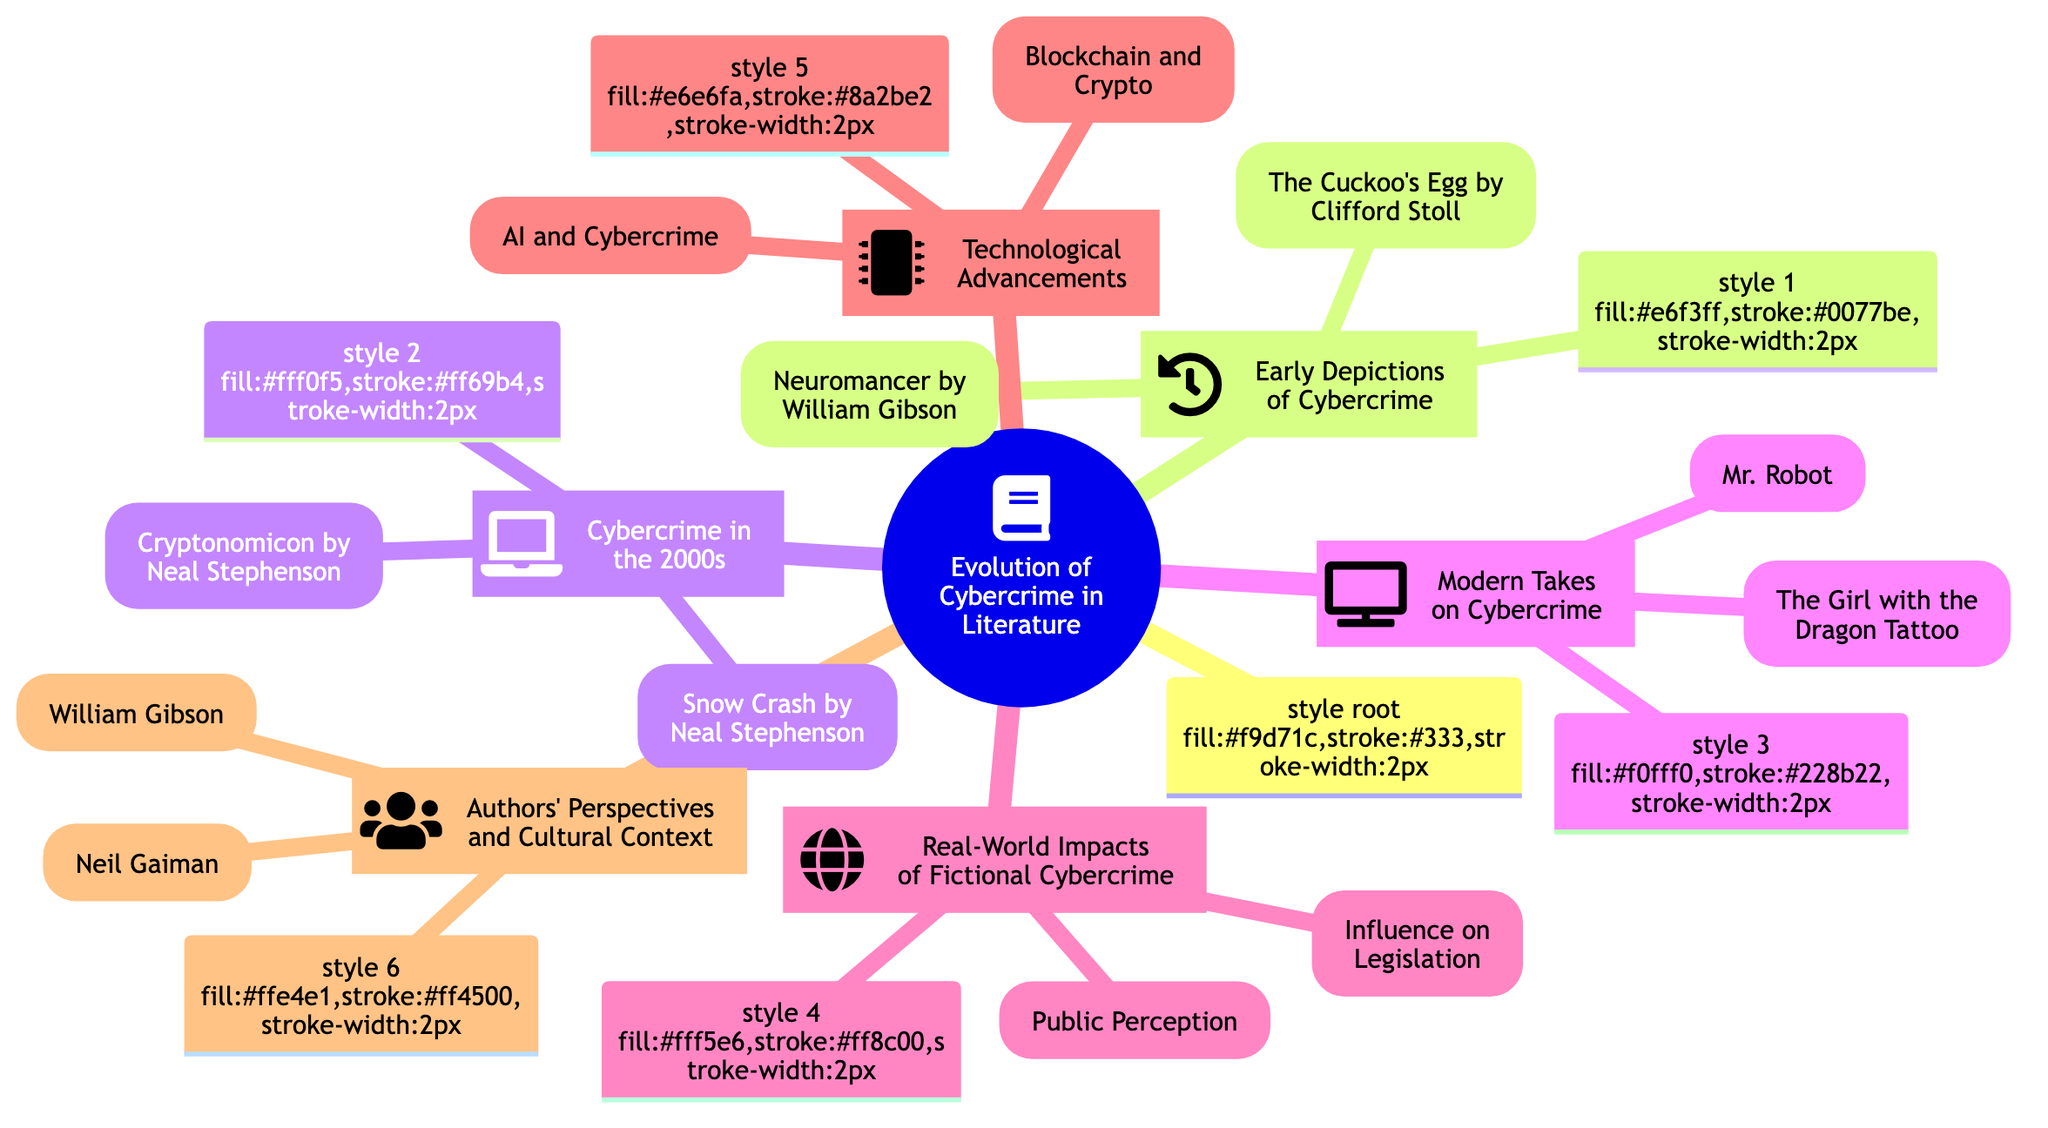What is the main topic of the mind map? The mind map's main topic is indicated at the center, which is "Evolution of Cybercrime in Literature."
Answer: Evolution of Cybercrime in Literature How many subtopics are there in the mind map? The mind map contains six distinct subtopics branching out from the central theme, labeled as Early Depictions of Cybercrime, Cybercrime in the 2000s, Modern Takes on Cybercrime, Real-World Impacts of Fictional Cybercrime, Technological Advancements, and Authors' Perspectives and Cultural Context.
Answer: 6 Which author is associated with the novel "Neuromancer"? The novel "Neuromancer" is linked to the author William Gibson, denoted in the Early Depictions of Cybercrime subtopic.
Answer: William Gibson What is one key element of modern takes on cybercrime? The mind map lists "Mr. Robot" as a significant element under the Modern Takes on Cybercrime, reflecting contemporary interpretations of the topic.
Answer: Mr. Robot Which subtopic addresses the influence of fiction on legislation? The Real-World Impacts of Fictional Cybercrime subtopic explicitly mentions "Influence on Legislation," highlighting how fictional representations can affect real-life laws and policies.
Answer: Influence on Legislation What are the two technological advancements mentioned in relation to cybercrime? The Technological Advancements subtopic lists two elements: "AI and Cybercrime" and "Blockchain and Crypto," indicating key modern technologies connected to cybercrime.
Answer: AI and Cybercrime; Blockchain and Crypto What thematic element is shared by the works of both William Gibson and Neil Gaiman? Both authors incorporate themes related to technology and its complexities, with Gibson being a pioneer of the cyberpunk genre and Gaiman sometimes exploring technology's darker misuse in his narratives.
Answer: Technology and its complexities In which decade does "The Cuckoo's Egg" focus on cybercrime? This non-fiction work centers on tracking a hacker specifically in the 1980s, as indicated in the Early Depictions of Cybercrime subtopic.
Answer: 1980s What psychological aspect does "Mr. Robot" explore in its depiction of cybercrime? "Mr. Robot" delves into the psychology of hacking culture as part of its narrative focus, showcasing a deeper understanding of cybercriminal behavior.
Answer: Psychology of hacking culture 